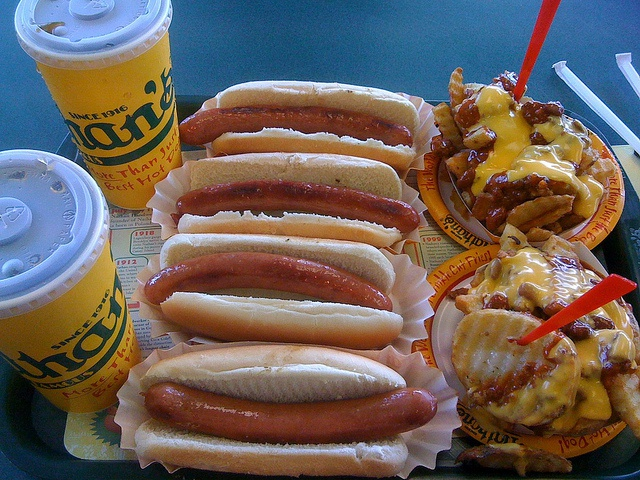Describe the objects in this image and their specific colors. I can see dining table in gray, blue, and lavender tones, hot dog in gray, maroon, and darkgray tones, cup in gray, olive, lightblue, and black tones, hot dog in gray, maroon, darkgray, and brown tones, and cup in gray, olive, lightblue, black, and darkgray tones in this image. 